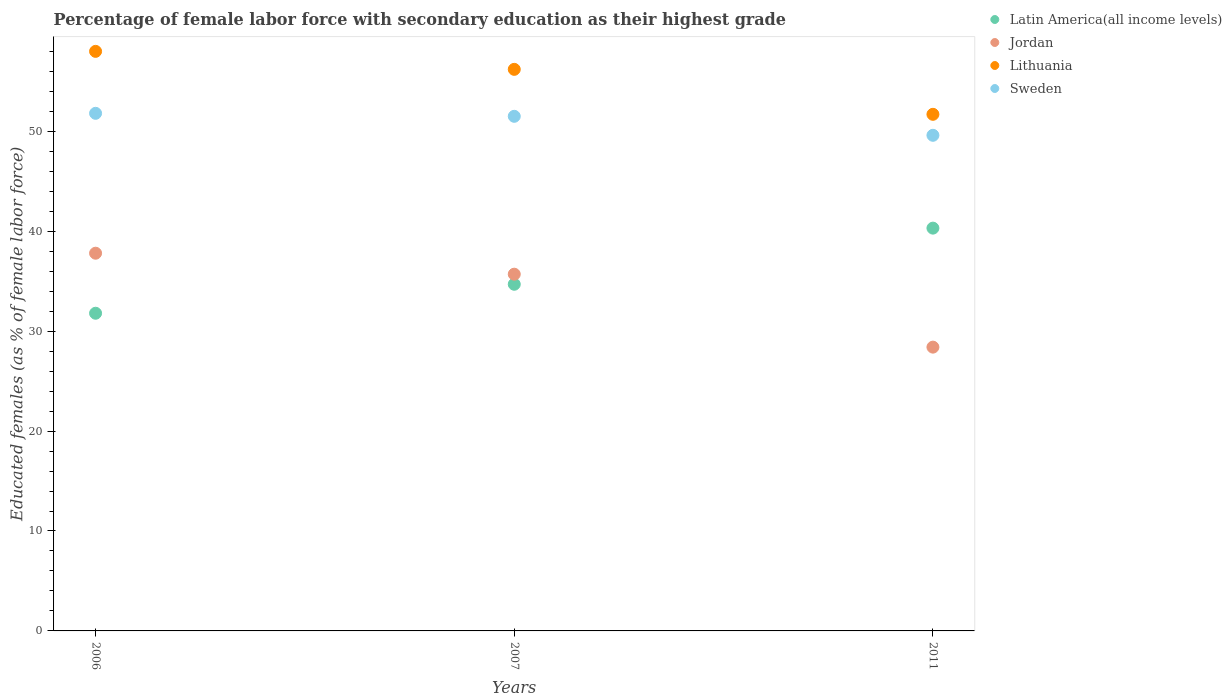How many different coloured dotlines are there?
Your answer should be very brief. 4. What is the percentage of female labor force with secondary education in Latin America(all income levels) in 2011?
Keep it short and to the point. 40.31. Across all years, what is the maximum percentage of female labor force with secondary education in Lithuania?
Provide a succinct answer. 58. Across all years, what is the minimum percentage of female labor force with secondary education in Jordan?
Your response must be concise. 28.4. In which year was the percentage of female labor force with secondary education in Jordan maximum?
Ensure brevity in your answer.  2006. In which year was the percentage of female labor force with secondary education in Jordan minimum?
Make the answer very short. 2011. What is the total percentage of female labor force with secondary education in Jordan in the graph?
Give a very brief answer. 101.9. What is the difference between the percentage of female labor force with secondary education in Sweden in 2007 and that in 2011?
Your response must be concise. 1.9. What is the difference between the percentage of female labor force with secondary education in Latin America(all income levels) in 2006 and the percentage of female labor force with secondary education in Sweden in 2007?
Give a very brief answer. -19.71. What is the average percentage of female labor force with secondary education in Lithuania per year?
Make the answer very short. 55.3. In the year 2007, what is the difference between the percentage of female labor force with secondary education in Lithuania and percentage of female labor force with secondary education in Latin America(all income levels)?
Offer a terse response. 21.51. What is the ratio of the percentage of female labor force with secondary education in Jordan in 2007 to that in 2011?
Ensure brevity in your answer.  1.26. Is the difference between the percentage of female labor force with secondary education in Lithuania in 2006 and 2011 greater than the difference between the percentage of female labor force with secondary education in Latin America(all income levels) in 2006 and 2011?
Your answer should be compact. Yes. What is the difference between the highest and the second highest percentage of female labor force with secondary education in Latin America(all income levels)?
Make the answer very short. 5.62. What is the difference between the highest and the lowest percentage of female labor force with secondary education in Jordan?
Your answer should be very brief. 9.4. Is the sum of the percentage of female labor force with secondary education in Latin America(all income levels) in 2007 and 2011 greater than the maximum percentage of female labor force with secondary education in Sweden across all years?
Provide a succinct answer. Yes. Is it the case that in every year, the sum of the percentage of female labor force with secondary education in Sweden and percentage of female labor force with secondary education in Jordan  is greater than the sum of percentage of female labor force with secondary education in Latin America(all income levels) and percentage of female labor force with secondary education in Lithuania?
Your response must be concise. Yes. Does the percentage of female labor force with secondary education in Sweden monotonically increase over the years?
Offer a very short reply. No. How many dotlines are there?
Make the answer very short. 4. How many years are there in the graph?
Give a very brief answer. 3. Are the values on the major ticks of Y-axis written in scientific E-notation?
Offer a terse response. No. Does the graph contain any zero values?
Your response must be concise. No. How many legend labels are there?
Keep it short and to the point. 4. How are the legend labels stacked?
Your response must be concise. Vertical. What is the title of the graph?
Keep it short and to the point. Percentage of female labor force with secondary education as their highest grade. Does "Romania" appear as one of the legend labels in the graph?
Offer a very short reply. No. What is the label or title of the Y-axis?
Give a very brief answer. Educated females (as % of female labor force). What is the Educated females (as % of female labor force) of Latin America(all income levels) in 2006?
Provide a short and direct response. 31.79. What is the Educated females (as % of female labor force) of Jordan in 2006?
Offer a very short reply. 37.8. What is the Educated females (as % of female labor force) in Sweden in 2006?
Give a very brief answer. 51.8. What is the Educated females (as % of female labor force) of Latin America(all income levels) in 2007?
Provide a short and direct response. 34.69. What is the Educated females (as % of female labor force) in Jordan in 2007?
Offer a very short reply. 35.7. What is the Educated females (as % of female labor force) of Lithuania in 2007?
Provide a short and direct response. 56.2. What is the Educated females (as % of female labor force) in Sweden in 2007?
Give a very brief answer. 51.5. What is the Educated females (as % of female labor force) in Latin America(all income levels) in 2011?
Your answer should be very brief. 40.31. What is the Educated females (as % of female labor force) of Jordan in 2011?
Provide a succinct answer. 28.4. What is the Educated females (as % of female labor force) of Lithuania in 2011?
Provide a succinct answer. 51.7. What is the Educated females (as % of female labor force) of Sweden in 2011?
Provide a short and direct response. 49.6. Across all years, what is the maximum Educated females (as % of female labor force) in Latin America(all income levels)?
Your response must be concise. 40.31. Across all years, what is the maximum Educated females (as % of female labor force) in Jordan?
Keep it short and to the point. 37.8. Across all years, what is the maximum Educated females (as % of female labor force) of Sweden?
Provide a succinct answer. 51.8. Across all years, what is the minimum Educated females (as % of female labor force) in Latin America(all income levels)?
Give a very brief answer. 31.79. Across all years, what is the minimum Educated females (as % of female labor force) in Jordan?
Ensure brevity in your answer.  28.4. Across all years, what is the minimum Educated females (as % of female labor force) in Lithuania?
Keep it short and to the point. 51.7. Across all years, what is the minimum Educated females (as % of female labor force) in Sweden?
Your answer should be compact. 49.6. What is the total Educated females (as % of female labor force) in Latin America(all income levels) in the graph?
Your answer should be very brief. 106.79. What is the total Educated females (as % of female labor force) of Jordan in the graph?
Your answer should be compact. 101.9. What is the total Educated females (as % of female labor force) in Lithuania in the graph?
Give a very brief answer. 165.9. What is the total Educated females (as % of female labor force) in Sweden in the graph?
Your response must be concise. 152.9. What is the difference between the Educated females (as % of female labor force) in Latin America(all income levels) in 2006 and that in 2007?
Provide a short and direct response. -2.9. What is the difference between the Educated females (as % of female labor force) in Latin America(all income levels) in 2006 and that in 2011?
Offer a terse response. -8.52. What is the difference between the Educated females (as % of female labor force) in Sweden in 2006 and that in 2011?
Your response must be concise. 2.2. What is the difference between the Educated females (as % of female labor force) of Latin America(all income levels) in 2007 and that in 2011?
Provide a short and direct response. -5.62. What is the difference between the Educated females (as % of female labor force) in Lithuania in 2007 and that in 2011?
Provide a succinct answer. 4.5. What is the difference between the Educated females (as % of female labor force) of Sweden in 2007 and that in 2011?
Offer a very short reply. 1.9. What is the difference between the Educated females (as % of female labor force) of Latin America(all income levels) in 2006 and the Educated females (as % of female labor force) of Jordan in 2007?
Your response must be concise. -3.91. What is the difference between the Educated females (as % of female labor force) in Latin America(all income levels) in 2006 and the Educated females (as % of female labor force) in Lithuania in 2007?
Provide a succinct answer. -24.41. What is the difference between the Educated females (as % of female labor force) of Latin America(all income levels) in 2006 and the Educated females (as % of female labor force) of Sweden in 2007?
Offer a terse response. -19.71. What is the difference between the Educated females (as % of female labor force) of Jordan in 2006 and the Educated females (as % of female labor force) of Lithuania in 2007?
Give a very brief answer. -18.4. What is the difference between the Educated females (as % of female labor force) in Jordan in 2006 and the Educated females (as % of female labor force) in Sweden in 2007?
Ensure brevity in your answer.  -13.7. What is the difference between the Educated females (as % of female labor force) of Lithuania in 2006 and the Educated females (as % of female labor force) of Sweden in 2007?
Offer a very short reply. 6.5. What is the difference between the Educated females (as % of female labor force) in Latin America(all income levels) in 2006 and the Educated females (as % of female labor force) in Jordan in 2011?
Make the answer very short. 3.39. What is the difference between the Educated females (as % of female labor force) in Latin America(all income levels) in 2006 and the Educated females (as % of female labor force) in Lithuania in 2011?
Provide a short and direct response. -19.91. What is the difference between the Educated females (as % of female labor force) in Latin America(all income levels) in 2006 and the Educated females (as % of female labor force) in Sweden in 2011?
Keep it short and to the point. -17.81. What is the difference between the Educated females (as % of female labor force) in Jordan in 2006 and the Educated females (as % of female labor force) in Lithuania in 2011?
Offer a terse response. -13.9. What is the difference between the Educated females (as % of female labor force) of Jordan in 2006 and the Educated females (as % of female labor force) of Sweden in 2011?
Offer a terse response. -11.8. What is the difference between the Educated females (as % of female labor force) in Lithuania in 2006 and the Educated females (as % of female labor force) in Sweden in 2011?
Your answer should be very brief. 8.4. What is the difference between the Educated females (as % of female labor force) in Latin America(all income levels) in 2007 and the Educated females (as % of female labor force) in Jordan in 2011?
Keep it short and to the point. 6.29. What is the difference between the Educated females (as % of female labor force) in Latin America(all income levels) in 2007 and the Educated females (as % of female labor force) in Lithuania in 2011?
Give a very brief answer. -17.01. What is the difference between the Educated females (as % of female labor force) in Latin America(all income levels) in 2007 and the Educated females (as % of female labor force) in Sweden in 2011?
Keep it short and to the point. -14.91. What is the difference between the Educated females (as % of female labor force) of Jordan in 2007 and the Educated females (as % of female labor force) of Lithuania in 2011?
Give a very brief answer. -16. What is the average Educated females (as % of female labor force) in Latin America(all income levels) per year?
Your answer should be compact. 35.6. What is the average Educated females (as % of female labor force) in Jordan per year?
Keep it short and to the point. 33.97. What is the average Educated females (as % of female labor force) of Lithuania per year?
Make the answer very short. 55.3. What is the average Educated females (as % of female labor force) in Sweden per year?
Your answer should be very brief. 50.97. In the year 2006, what is the difference between the Educated females (as % of female labor force) of Latin America(all income levels) and Educated females (as % of female labor force) of Jordan?
Ensure brevity in your answer.  -6.01. In the year 2006, what is the difference between the Educated females (as % of female labor force) of Latin America(all income levels) and Educated females (as % of female labor force) of Lithuania?
Offer a very short reply. -26.21. In the year 2006, what is the difference between the Educated females (as % of female labor force) in Latin America(all income levels) and Educated females (as % of female labor force) in Sweden?
Your response must be concise. -20.01. In the year 2006, what is the difference between the Educated females (as % of female labor force) of Jordan and Educated females (as % of female labor force) of Lithuania?
Your answer should be very brief. -20.2. In the year 2006, what is the difference between the Educated females (as % of female labor force) in Lithuania and Educated females (as % of female labor force) in Sweden?
Ensure brevity in your answer.  6.2. In the year 2007, what is the difference between the Educated females (as % of female labor force) in Latin America(all income levels) and Educated females (as % of female labor force) in Jordan?
Ensure brevity in your answer.  -1.01. In the year 2007, what is the difference between the Educated females (as % of female labor force) of Latin America(all income levels) and Educated females (as % of female labor force) of Lithuania?
Give a very brief answer. -21.51. In the year 2007, what is the difference between the Educated females (as % of female labor force) in Latin America(all income levels) and Educated females (as % of female labor force) in Sweden?
Provide a succinct answer. -16.81. In the year 2007, what is the difference between the Educated females (as % of female labor force) of Jordan and Educated females (as % of female labor force) of Lithuania?
Provide a short and direct response. -20.5. In the year 2007, what is the difference between the Educated females (as % of female labor force) of Jordan and Educated females (as % of female labor force) of Sweden?
Provide a short and direct response. -15.8. In the year 2011, what is the difference between the Educated females (as % of female labor force) of Latin America(all income levels) and Educated females (as % of female labor force) of Jordan?
Your response must be concise. 11.91. In the year 2011, what is the difference between the Educated females (as % of female labor force) of Latin America(all income levels) and Educated females (as % of female labor force) of Lithuania?
Offer a very short reply. -11.39. In the year 2011, what is the difference between the Educated females (as % of female labor force) of Latin America(all income levels) and Educated females (as % of female labor force) of Sweden?
Your response must be concise. -9.29. In the year 2011, what is the difference between the Educated females (as % of female labor force) in Jordan and Educated females (as % of female labor force) in Lithuania?
Your answer should be compact. -23.3. In the year 2011, what is the difference between the Educated females (as % of female labor force) in Jordan and Educated females (as % of female labor force) in Sweden?
Keep it short and to the point. -21.2. In the year 2011, what is the difference between the Educated females (as % of female labor force) in Lithuania and Educated females (as % of female labor force) in Sweden?
Ensure brevity in your answer.  2.1. What is the ratio of the Educated females (as % of female labor force) of Latin America(all income levels) in 2006 to that in 2007?
Offer a very short reply. 0.92. What is the ratio of the Educated females (as % of female labor force) of Jordan in 2006 to that in 2007?
Give a very brief answer. 1.06. What is the ratio of the Educated females (as % of female labor force) of Lithuania in 2006 to that in 2007?
Keep it short and to the point. 1.03. What is the ratio of the Educated females (as % of female labor force) in Latin America(all income levels) in 2006 to that in 2011?
Your answer should be compact. 0.79. What is the ratio of the Educated females (as % of female labor force) in Jordan in 2006 to that in 2011?
Make the answer very short. 1.33. What is the ratio of the Educated females (as % of female labor force) in Lithuania in 2006 to that in 2011?
Offer a very short reply. 1.12. What is the ratio of the Educated females (as % of female labor force) of Sweden in 2006 to that in 2011?
Ensure brevity in your answer.  1.04. What is the ratio of the Educated females (as % of female labor force) of Latin America(all income levels) in 2007 to that in 2011?
Your response must be concise. 0.86. What is the ratio of the Educated females (as % of female labor force) in Jordan in 2007 to that in 2011?
Ensure brevity in your answer.  1.26. What is the ratio of the Educated females (as % of female labor force) in Lithuania in 2007 to that in 2011?
Your response must be concise. 1.09. What is the ratio of the Educated females (as % of female labor force) in Sweden in 2007 to that in 2011?
Your answer should be very brief. 1.04. What is the difference between the highest and the second highest Educated females (as % of female labor force) in Latin America(all income levels)?
Offer a very short reply. 5.62. What is the difference between the highest and the second highest Educated females (as % of female labor force) of Jordan?
Make the answer very short. 2.1. What is the difference between the highest and the second highest Educated females (as % of female labor force) in Lithuania?
Your response must be concise. 1.8. What is the difference between the highest and the lowest Educated females (as % of female labor force) of Latin America(all income levels)?
Ensure brevity in your answer.  8.52. What is the difference between the highest and the lowest Educated females (as % of female labor force) of Jordan?
Make the answer very short. 9.4. 